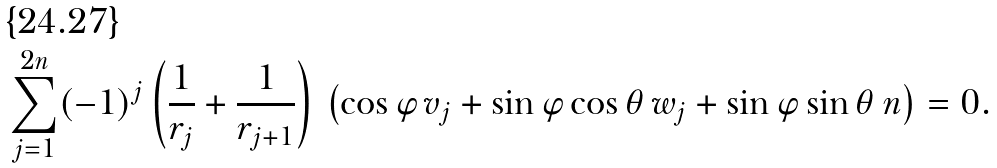<formula> <loc_0><loc_0><loc_500><loc_500>\sum _ { j = 1 } ^ { 2 n } ( - 1 ) ^ { j } \left ( \frac { 1 } { r _ { j } } + \frac { 1 } { r _ { j + 1 } } \right ) \, \left ( \cos \varphi \, v _ { j } + \sin \varphi \cos \theta \, w _ { j } + \sin \varphi \sin \theta \, n \right ) = 0 .</formula> 